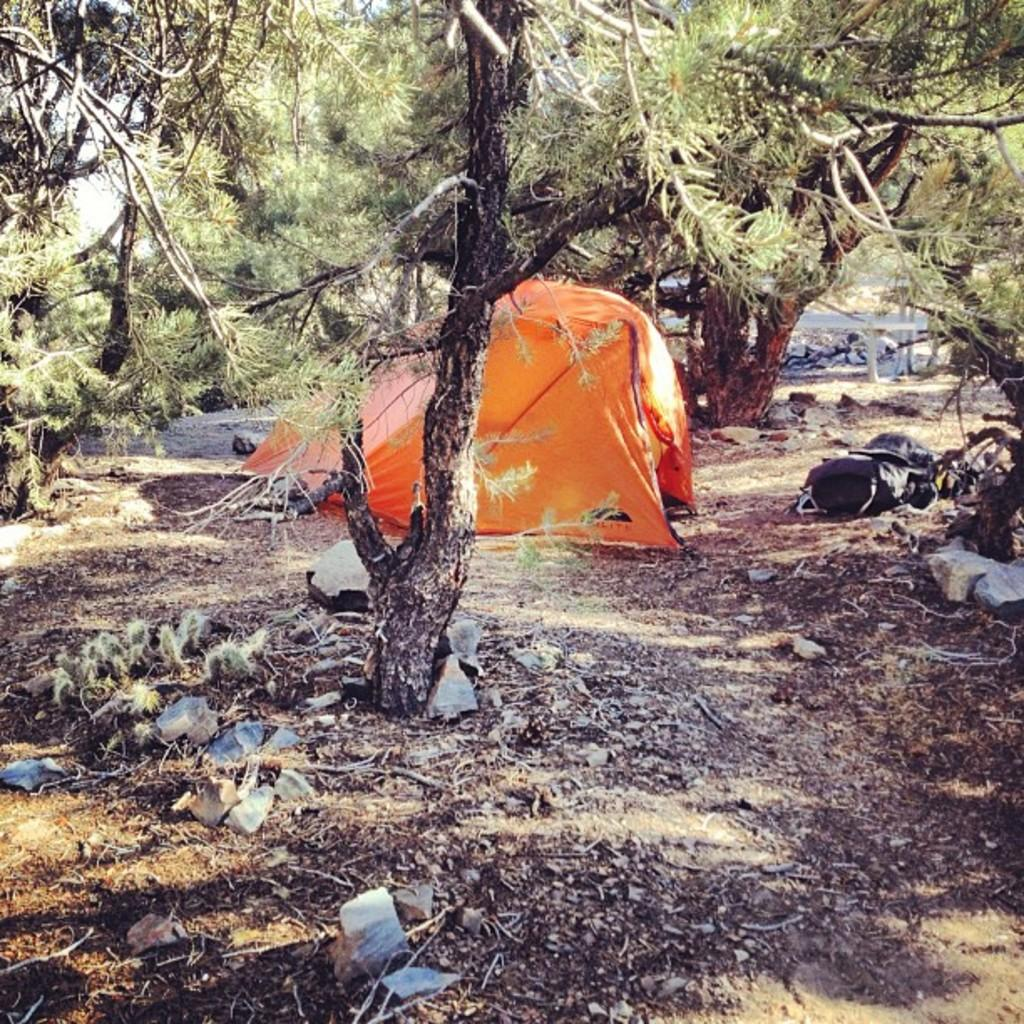What type of shelter is present in the image? There is a tent in the image. What object can be seen on the ground in the image? There is a bag on the ground in the image. What can be seen in the distance in the image? There are trees visible in the background of the image. How many people are in the crowd surrounding the cannon in the image? There is no crowd or cannon present in the image. What is the scale of the tent in the image? The scale of the tent cannot be determined from the image alone, as there is no reference point for comparison. 